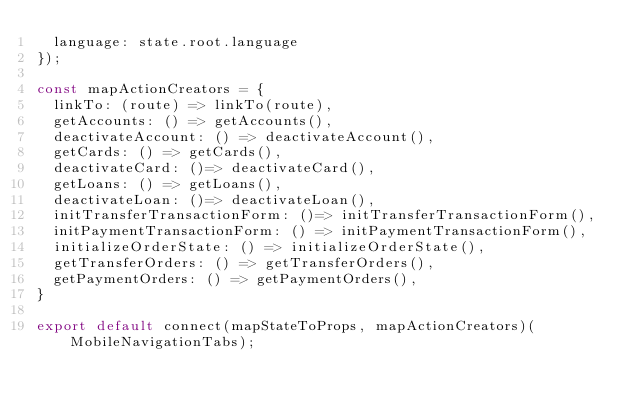<code> <loc_0><loc_0><loc_500><loc_500><_JavaScript_>  language: state.root.language
});

const mapActionCreators = {
  linkTo: (route) => linkTo(route),
  getAccounts: () => getAccounts(),
  deactivateAccount: () => deactivateAccount(),
  getCards: () => getCards(),
  deactivateCard: ()=> deactivateCard(),
  getLoans: () => getLoans(),
  deactivateLoan: ()=> deactivateLoan(),
  initTransferTransactionForm: ()=> initTransferTransactionForm(),
  initPaymentTransactionForm: () => initPaymentTransactionForm(),
  initializeOrderState: () => initializeOrderState(),
  getTransferOrders: () => getTransferOrders(),
  getPaymentOrders: () => getPaymentOrders(),
}

export default connect(mapStateToProps, mapActionCreators)(MobileNavigationTabs);
</code> 